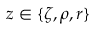<formula> <loc_0><loc_0><loc_500><loc_500>z \in \{ \zeta , \rho , r \}</formula> 